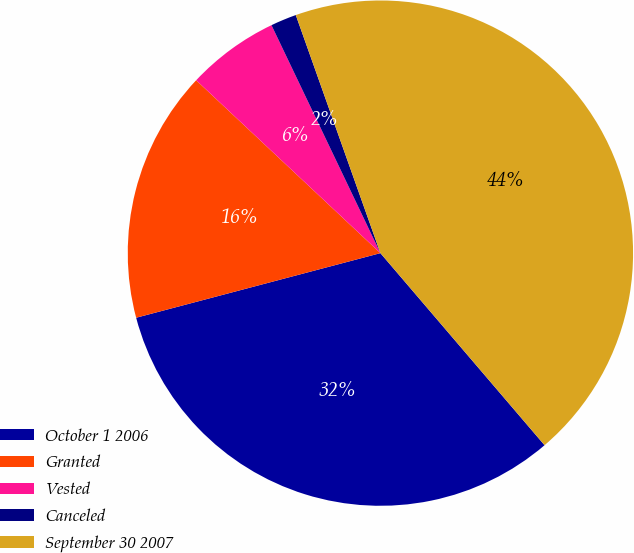<chart> <loc_0><loc_0><loc_500><loc_500><pie_chart><fcel>October 1 2006<fcel>Granted<fcel>Vested<fcel>Canceled<fcel>September 30 2007<nl><fcel>32.14%<fcel>16.11%<fcel>5.91%<fcel>1.66%<fcel>44.18%<nl></chart> 